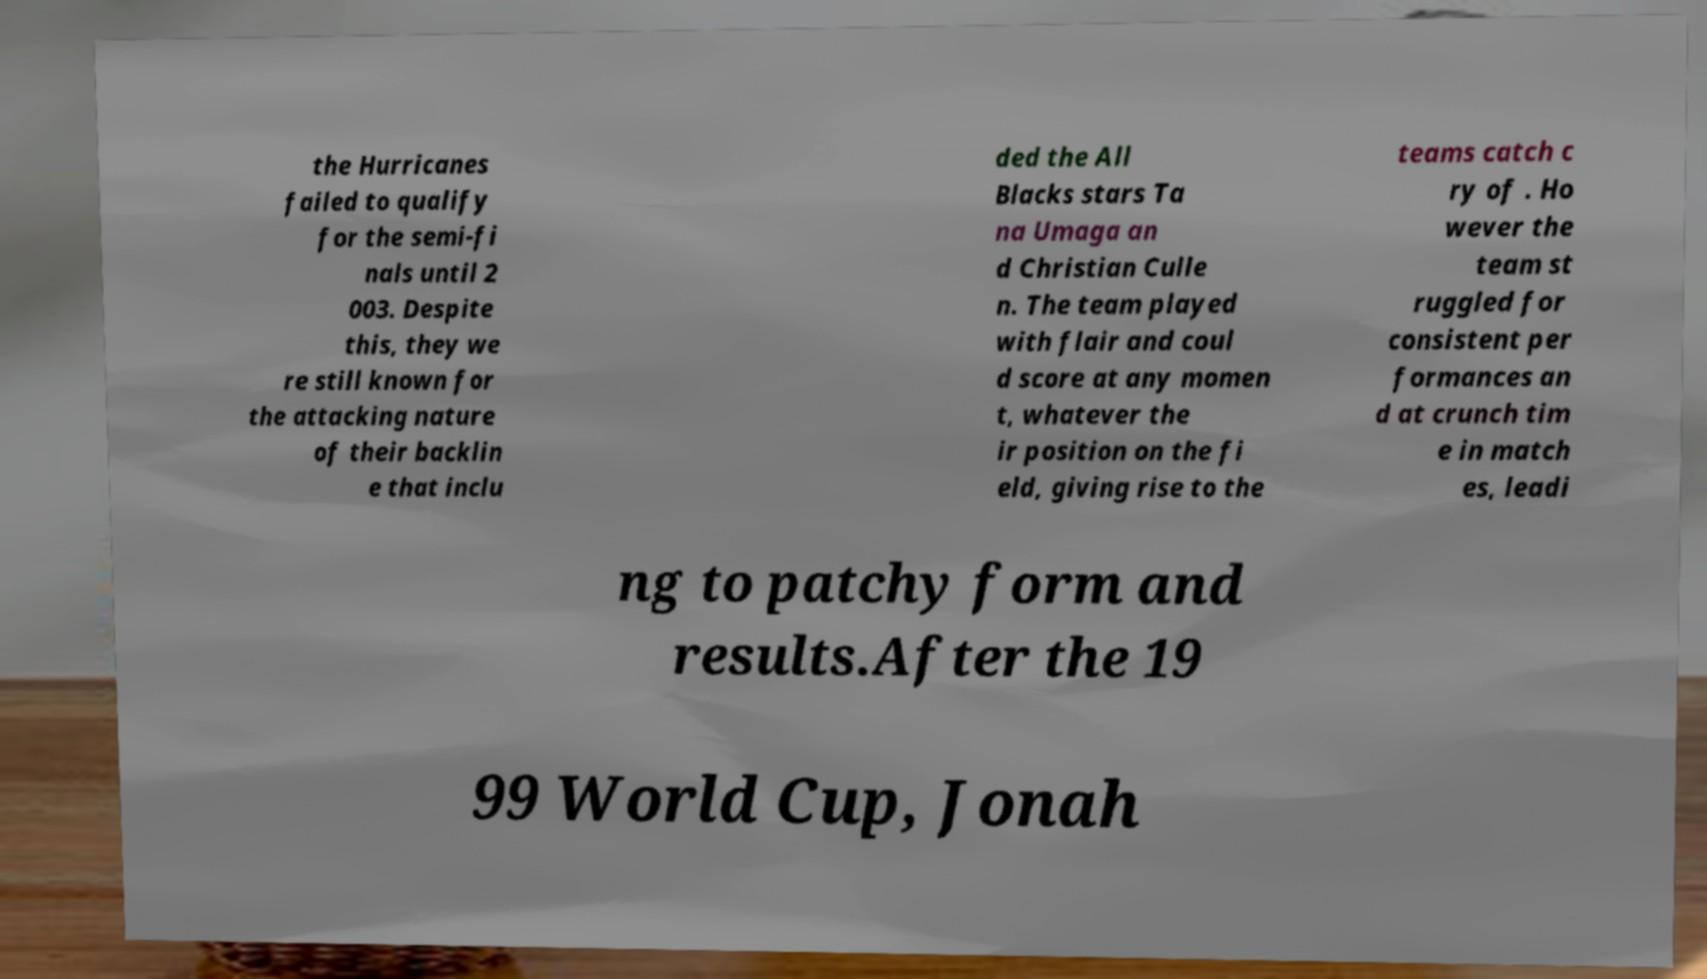What messages or text are displayed in this image? I need them in a readable, typed format. the Hurricanes failed to qualify for the semi-fi nals until 2 003. Despite this, they we re still known for the attacking nature of their backlin e that inclu ded the All Blacks stars Ta na Umaga an d Christian Culle n. The team played with flair and coul d score at any momen t, whatever the ir position on the fi eld, giving rise to the teams catch c ry of . Ho wever the team st ruggled for consistent per formances an d at crunch tim e in match es, leadi ng to patchy form and results.After the 19 99 World Cup, Jonah 